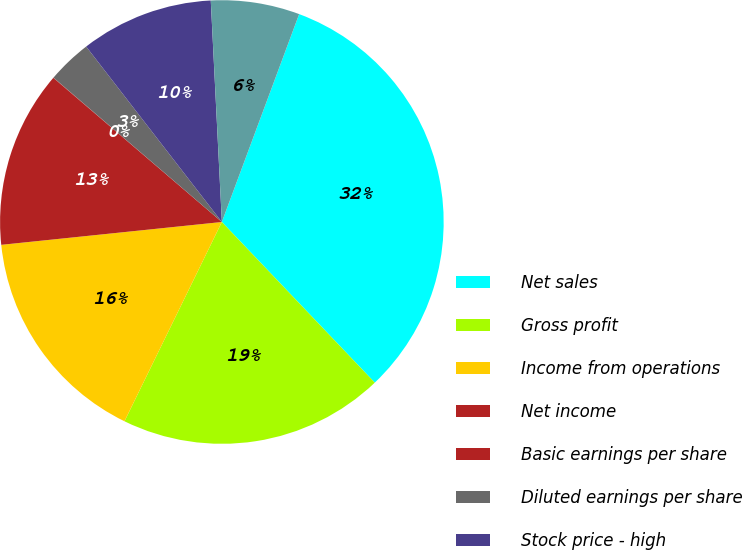Convert chart. <chart><loc_0><loc_0><loc_500><loc_500><pie_chart><fcel>Net sales<fcel>Gross profit<fcel>Income from operations<fcel>Net income<fcel>Basic earnings per share<fcel>Diluted earnings per share<fcel>Stock price - high<fcel>Stock price - low<nl><fcel>32.22%<fcel>19.34%<fcel>16.12%<fcel>12.9%<fcel>0.02%<fcel>3.24%<fcel>9.68%<fcel>6.46%<nl></chart> 